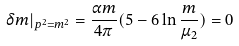Convert formula to latex. <formula><loc_0><loc_0><loc_500><loc_500>\delta m | _ { p ^ { 2 } = m ^ { 2 } } = \frac { \alpha m } { 4 \pi } ( 5 - 6 \ln \frac { m } { \mu _ { 2 } } ) = 0</formula> 